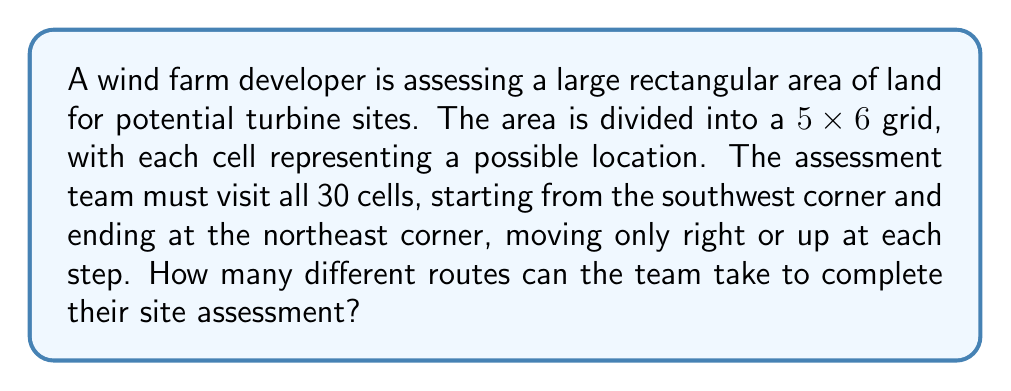Teach me how to tackle this problem. Let's approach this step-by-step:

1) This problem is a classic lattice path counting problem.

2) To reach the northeast corner from the southwest corner, the team must move:
   - 5 steps to the right (to cover the width)
   - 4 steps up (to cover the height)

3) The total number of steps is always 5 + 4 = 9, regardless of the route taken.

4) The question is essentially asking: in how many ways can we arrange 5 right moves and 4 up moves?

5) This is a combination problem. We need to choose the positions for either the right moves or the up moves out of the total 9 moves.

6) Let's choose the positions for the right moves. We need to choose 5 positions out of 9.

7) This can be represented as $\binom{9}{5}$ or $C(9,5)$.

8) The formula for this combination is:

   $$\binom{9}{5} = \frac{9!}{5!(9-5)!} = \frac{9!}{5!4!}$$

9) Calculating this:
   $$\frac{9 * 8 * 7 * 6 * 5 * 4!}{(5 * 4 * 3 * 2 * 1) * 4!} = \frac{3024}{120} = 252$$

Therefore, there are 252 different routes the team can take.
Answer: 252 